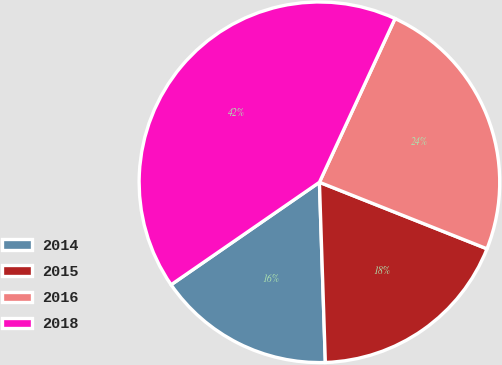Convert chart to OTSL. <chart><loc_0><loc_0><loc_500><loc_500><pie_chart><fcel>2014<fcel>2015<fcel>2016<fcel>2018<nl><fcel>15.9%<fcel>18.46%<fcel>24.13%<fcel>41.51%<nl></chart> 